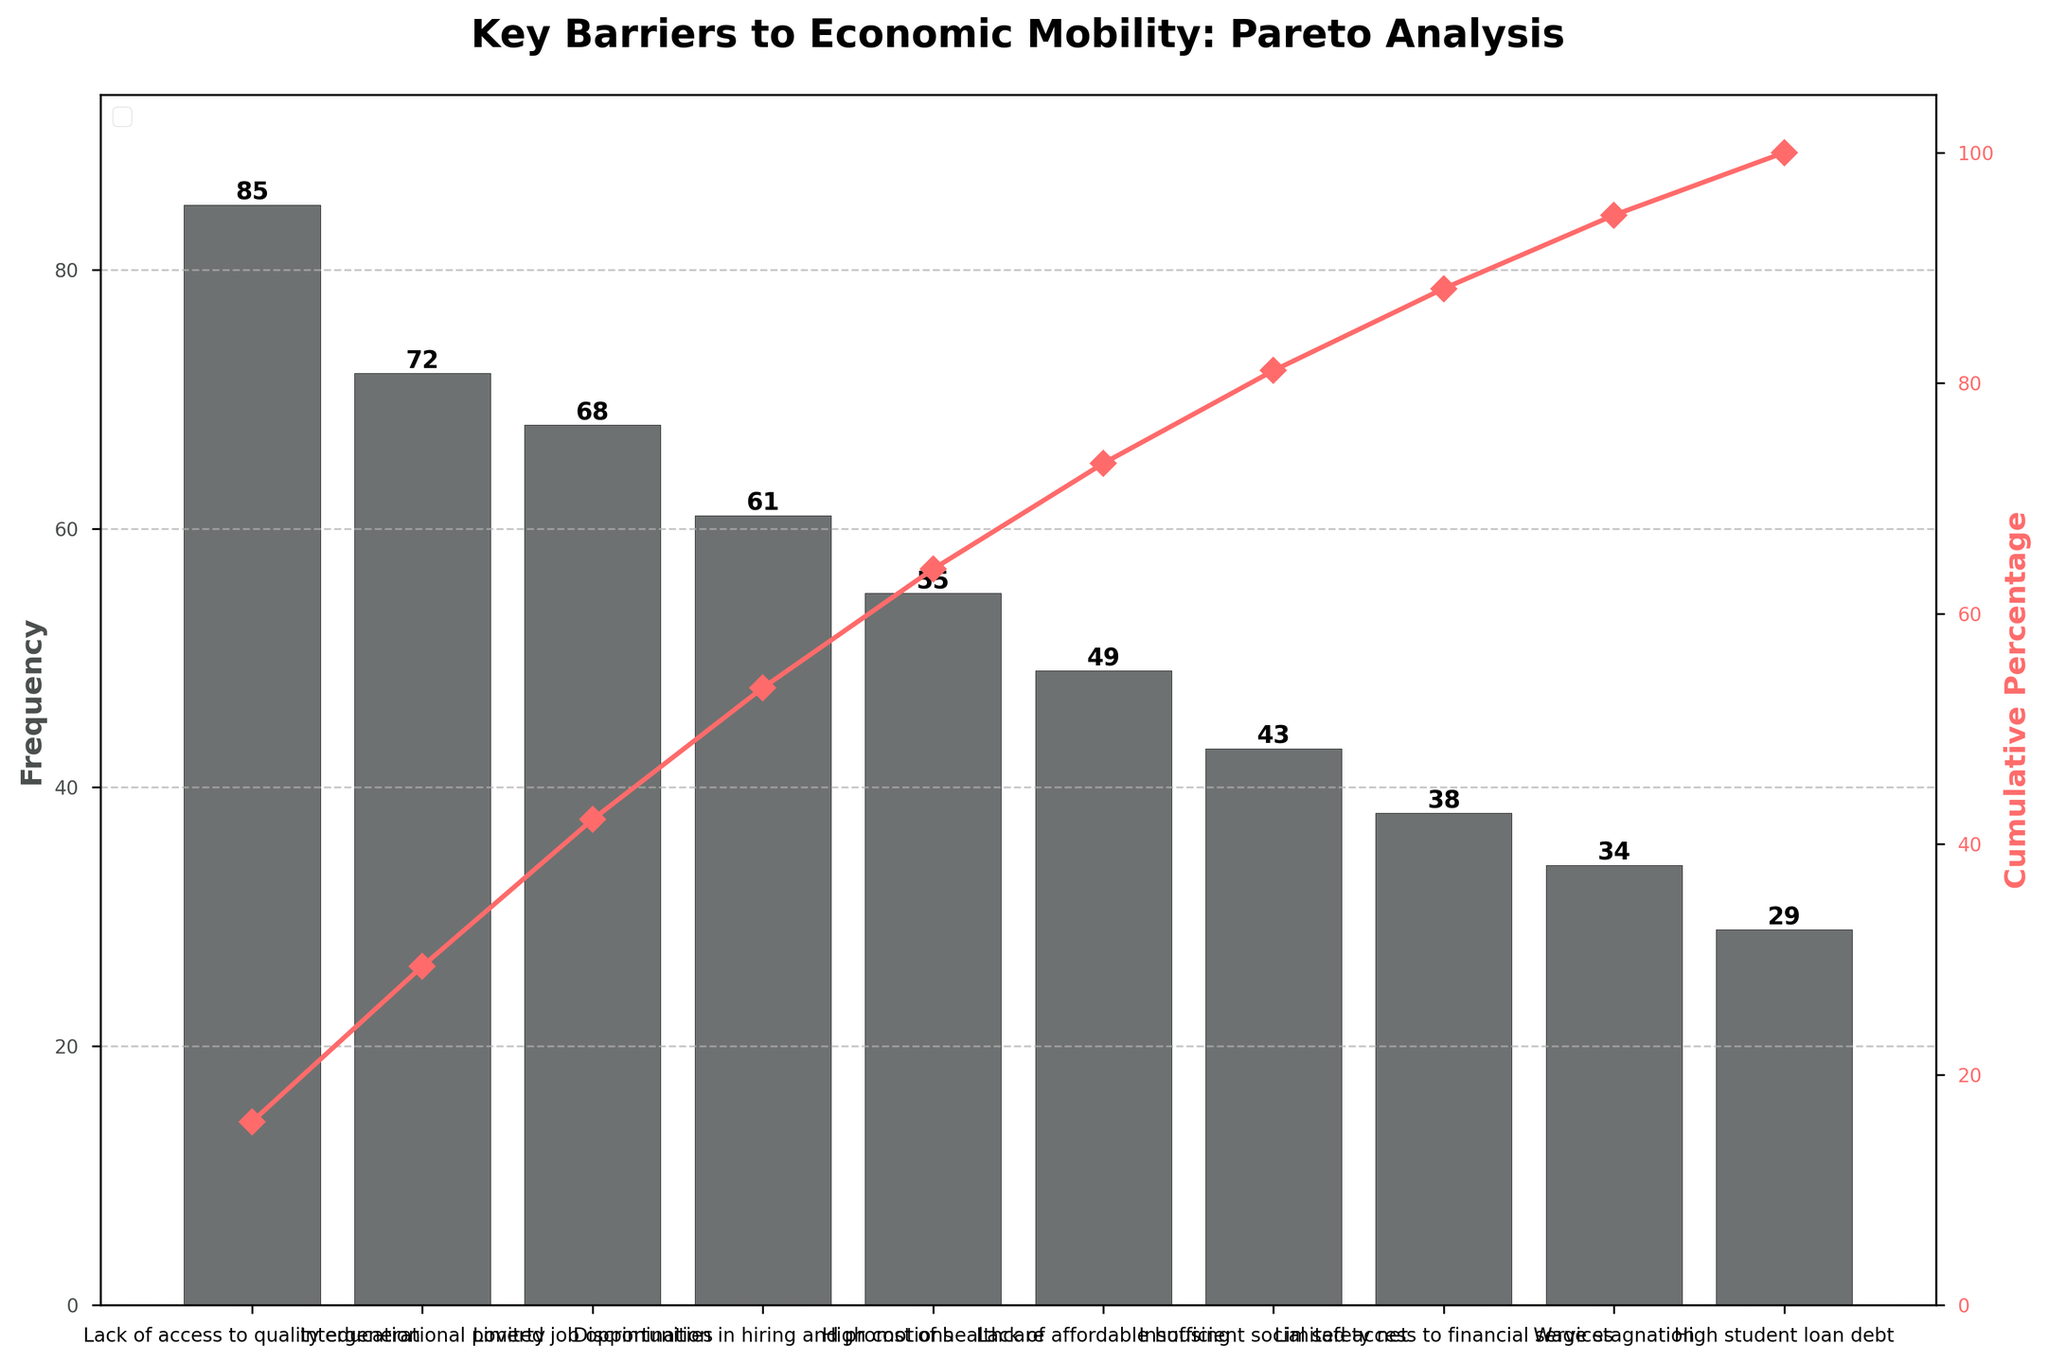What's the most frequently cited barrier to economic mobility? The Pareto chart shows that "Lack of access to quality education" has the highest bar, indicating it is the most frequently cited barrier.
Answer: Lack of access to quality education How many barriers contribute to over half (more than 50%) of the total frequency? The cumulative percentage line shows that the first three barriers ("Lack of access to quality education," "Intergenerational poverty," and "Limited job opportunities") together exceed 50%.
Answer: 3 How much higher is the frequency of "Lack of access to quality education" compared to "Discrimination in hiring and promotions"? The frequency of "Lack of access to quality education" is 85, and "Discrimination in hiring and promotions" is 61. The difference is 85 - 61.
Answer: 24 What is the cumulative percentage after considering the top 5 barriers? The chart shows that the cumulative percentage after the fifth barrier ("High cost of healthcare") is approximately 70%.
Answer: About 70% Which barrier has a frequency closest to the median of all listed barriers? There are 10 barriers, and the median frequency will be the average of the 5th and 6th values when sorted. The 5th and 6th barriers are "High cost of healthcare" (55) and "Lack of affordable housing" (49). The median is (55 + 49)/2 = 52, so the closest are the 5th ("High cost of healthcare") and 6th ("Lack of affordable housing").
Answer: High cost of healthcare and Lack of affordable housing Which barriers are listed under the cumulative percentage of 100% but over 90%? The chart shows that "Wage stagnation" and "High student loan debt" are added after achieving a cumulative percentage of 90% but before 100%.
Answer: Wage stagnation and High student loan debt How many barriers are included to reach a cumulative percentage of approximately 85%? The Pareto chart shows that the cumulative percentage is approximately 85% when the first seven barriers ("Lack of access to quality education" to "Insufficient social safety net") are included.
Answer: 7 What is the frequency difference between the least and second-least cited barriers? The least cited barrier is "High student loan debt" with 29, and the second-least is "Wage stagnation" with 34. The difference is 34 - 29.
Answer: 5 